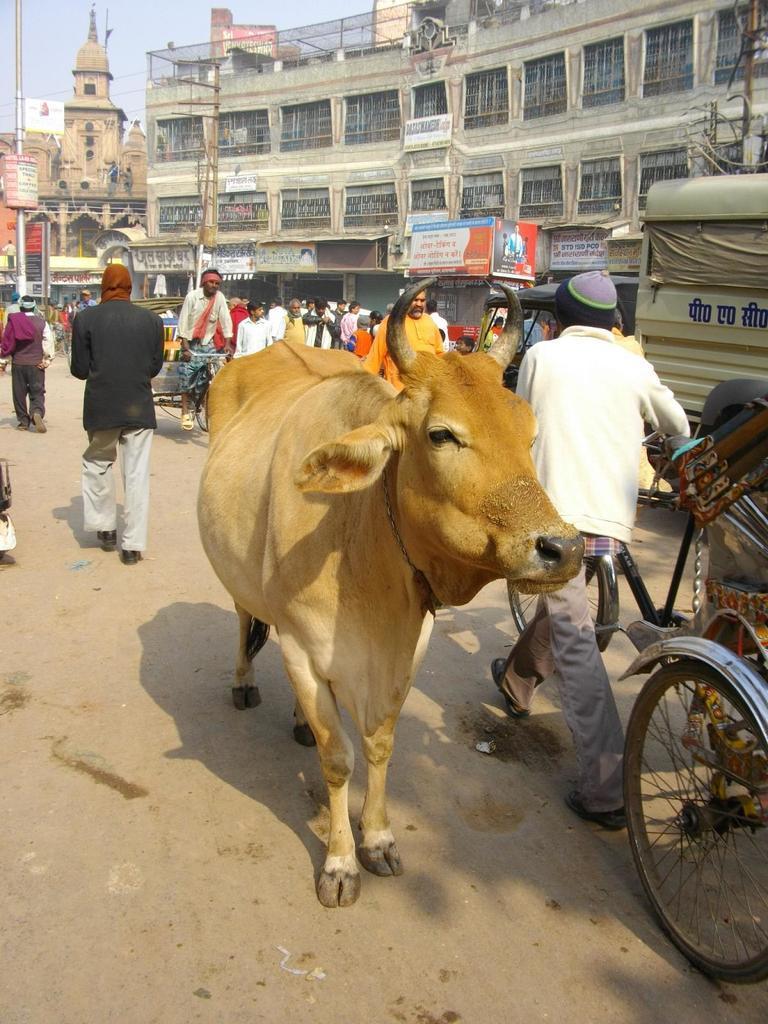How would you summarize this image in a sentence or two? In this picture I can see the road, on which we can see a cow, vehicles, some people are on the road, around we can see some buildings to which we can see some boards. 